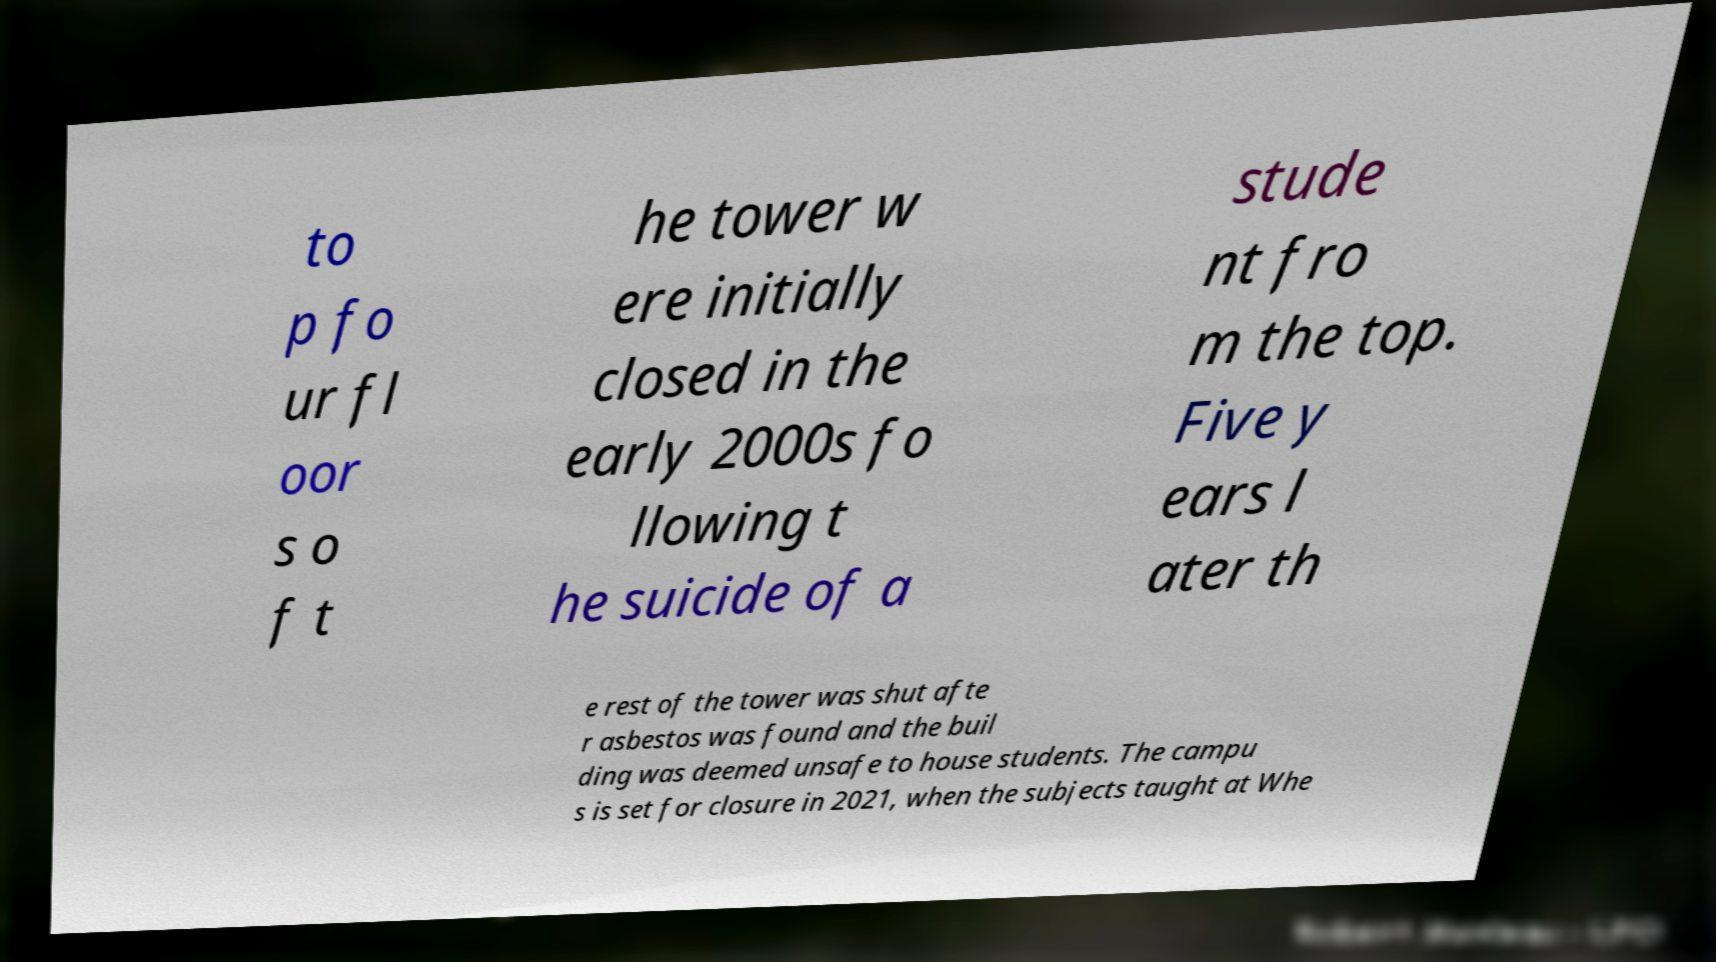Could you extract and type out the text from this image? to p fo ur fl oor s o f t he tower w ere initially closed in the early 2000s fo llowing t he suicide of a stude nt fro m the top. Five y ears l ater th e rest of the tower was shut afte r asbestos was found and the buil ding was deemed unsafe to house students. The campu s is set for closure in 2021, when the subjects taught at Whe 